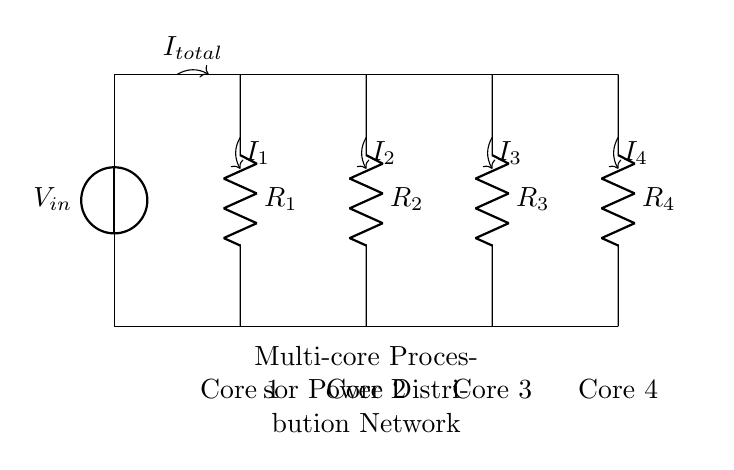What is the input voltage of the circuit? The input voltage is indicated by the voltage source labeled V_in, which is present at the top of the circuit.
Answer: V_in What are the resistance values in the circuit? The circuit contains four resistors labeled as R_1, R_2, R_3, and R_4, but their exact values are not specified in the diagram.
Answer: R_1, R_2, R_3, R_4 How many cores does this power distribution network support? The diagram includes labels for four cores, indicating that it supports four cores in total.
Answer: Four What is the total current entering the circuit? The total current is labeled as I_total with an arrow directed towards the first resistor, indicating the current entering the circuit.
Answer: I_total What can you infer about the distribution of current in the branches? The current is divided among the branches due to the presence of multiple resistors, and each current I_1, I_2, I_3, and I_4 flows through the respective resistors R_1, R_2, R_3, and R_4.
Answer: Current division If R_1 is less than R_2, how does that affect I_1 compared to I_2? According to the current divider rule, if R_1 has a smaller resistance compared to R_2, I_1 will be greater than I_2 since current flows more through the path of lower resistance.
Answer: I_1 > I_2 In this circuit, what is the effect of increasing R_3 while keeping other resistances constant? Increasing R_3 will decrease the current I_3 flowing through it due to the increased resistance, leading to a redistributing of current among the other branches, according to the current divider principles.
Answer: I_3 decreases 